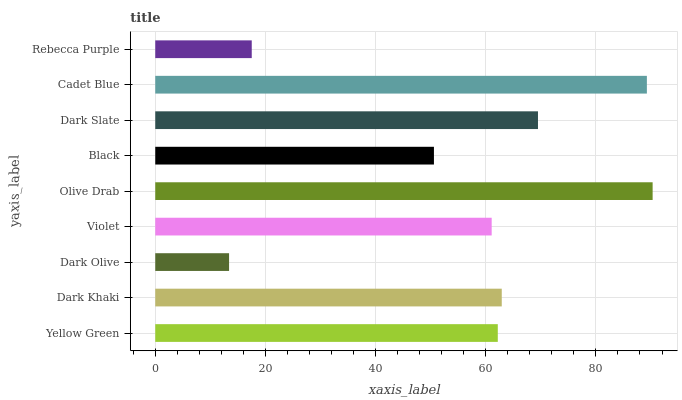Is Dark Olive the minimum?
Answer yes or no. Yes. Is Olive Drab the maximum?
Answer yes or no. Yes. Is Dark Khaki the minimum?
Answer yes or no. No. Is Dark Khaki the maximum?
Answer yes or no. No. Is Dark Khaki greater than Yellow Green?
Answer yes or no. Yes. Is Yellow Green less than Dark Khaki?
Answer yes or no. Yes. Is Yellow Green greater than Dark Khaki?
Answer yes or no. No. Is Dark Khaki less than Yellow Green?
Answer yes or no. No. Is Yellow Green the high median?
Answer yes or no. Yes. Is Yellow Green the low median?
Answer yes or no. Yes. Is Cadet Blue the high median?
Answer yes or no. No. Is Rebecca Purple the low median?
Answer yes or no. No. 